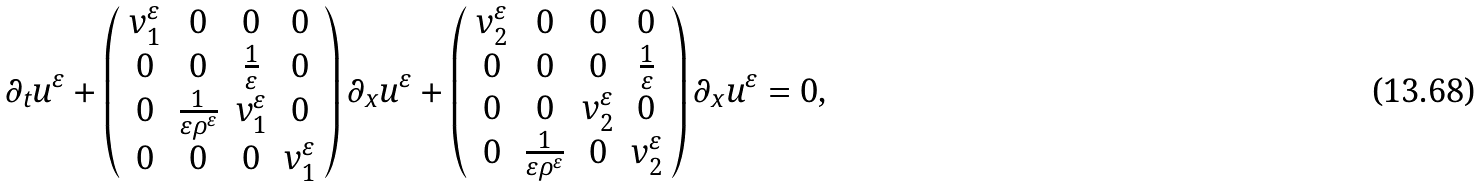Convert formula to latex. <formula><loc_0><loc_0><loc_500><loc_500>\partial _ { t } u ^ { \varepsilon } + \left ( \begin{array} { c c c c } v ^ { \varepsilon } _ { 1 } & 0 & 0 & 0 \\ 0 & 0 & \frac { 1 } { \varepsilon } & 0 \\ 0 & \frac { 1 } { \varepsilon \rho ^ { \varepsilon } } & v ^ { \varepsilon } _ { 1 } & 0 \\ 0 & 0 & 0 & v ^ { \varepsilon } _ { 1 } \end{array} \right ) \partial _ { x } u ^ { \varepsilon } + \left ( \begin{array} { c c c c } v ^ { \varepsilon } _ { 2 } & 0 & 0 & 0 \\ 0 & 0 & 0 & \frac { 1 } { \varepsilon } \\ 0 & 0 & v ^ { \varepsilon } _ { 2 } & 0 \\ 0 & \frac { 1 } { \varepsilon \rho ^ { \varepsilon } } & 0 & v ^ { \varepsilon } _ { 2 } \end{array} \right ) \partial _ { x } u ^ { \varepsilon } = 0 ,</formula> 